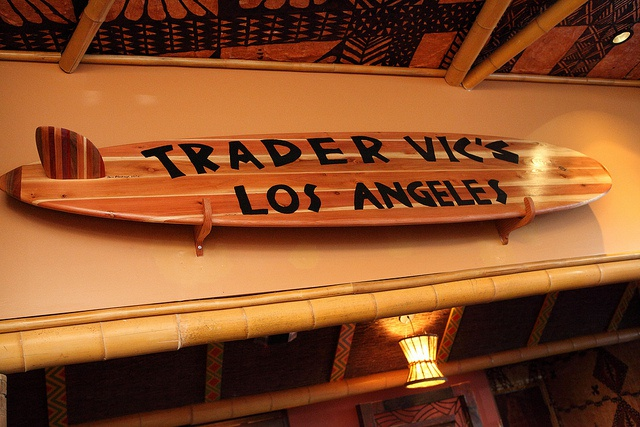Describe the objects in this image and their specific colors. I can see a surfboard in maroon, red, brown, black, and tan tones in this image. 